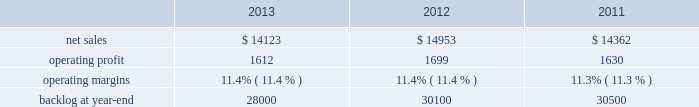Aeronautics our aeronautics business segment is engaged in the research , design , development , manufacture , integration , sustainment , support , and upgrade of advanced military aircraft , including combat and air mobility aircraft , unmanned air vehicles , and related technologies .
Aeronautics 2019 major programs include the f-35 lightning ii joint strike fighter , c-130 hercules , f-16 fighting falcon , f-22 raptor , and the c-5m super galaxy .
Aeronautics 2019 operating results included the following ( in millions ) : .
2013 compared to 2012 aeronautics 2019 net sales for 2013 decreased $ 830 million , or 6% ( 6 % ) , compared to 2012 .
The decrease was primarily attributable to lower net sales of approximately $ 530 million for the f-16 program due to fewer aircraft deliveries ( 13 aircraft delivered in 2013 compared to 37 delivered in 2012 ) partially offset by aircraft configuration mix ; about $ 385 million for the c-130 program due to fewer aircraft deliveries ( 25 aircraft delivered in 2013 compared to 34 in 2012 ) partially offset by increased sustainment activities ; approximately $ 255 million for the f-22 program , which includes about $ 205 million due to decreased production volume as final aircraft deliveries were completed during the second quarter of 2012 and $ 50 million from the favorable resolution of a contractual matter during the second quarter of 2012 ; and about $ 270 million for various other programs ( primarily sustainment activities ) due to decreased volume .
The decreases were partially offset by higher net sales of about $ 295 million for f-35 production contracts due to increased production volume and risk retirements ; approximately $ 245 million for the c-5 program due to increased aircraft deliveries ( six aircraft delivered in 2013 compared to four in 2012 ) and other modernization activities ; and about $ 70 million for the f-35 development contract due to increased volume .
Aeronautics 2019 operating profit for 2013 decreased $ 87 million , or 5% ( 5 % ) , compared to 2012 .
The decrease was primarily attributable to lower operating profit of about $ 85 million for the f-22 program , which includes approximately $ 50 million from the favorable resolution of a contractual matter in the second quarter of 2012 and about $ 35 million due to decreased risk retirements and production volume ; approximately $ 70 million for the c-130 program due to lower risk retirements and fewer deliveries partially offset by increased sustainment activities ; about $ 65 million for the c-5 program due to the inception-to-date effect of reducing the profit booking rate in the third quarter of 2013 and lower risk retirements ; approximately $ 35 million for the f-16 program due to fewer aircraft deliveries partially offset by increased sustainment activity and aircraft configuration mix .
The decreases were partially offset by higher operating profit of approximately $ 180 million for f-35 production contracts due to increased risk retirements and volume .
Operating profit was comparable for the f-35 development contract and included adjustments of approximately $ 85 million to reflect the inception-to-date impacts of the downward revisions to the profit booking rate in both 2013 and 2012 .
Adjustments not related to volume , including net profit booking rate adjustments and other matters , were approximately $ 75 million lower for 2013 compared to 2012 compared to 2011 aeronautics 2019 net sales for 2012 increased $ 591 million , or 4% ( 4 % ) , compared to 2011 .
The increase was attributable to higher net sales of approximately $ 745 million from f-35 production contracts principally due to increased production volume ; about $ 285 million from f-16 programs primarily due to higher aircraft deliveries ( 37 f-16 aircraft delivered in 2012 compared to 22 in 2011 ) partially offset by lower volume on sustainment activities due to the completion of modification programs for certain international customers ; and approximately $ 140 million from c-5 programs due to higher aircraft deliveries ( four c-5m aircraft delivered in 2012 compared to two in 2011 ) .
Partially offsetting the increases were lower net sales of approximately $ 365 million from decreased production volume and lower risk retirements on the f-22 program as final aircraft deliveries were completed in the second quarter of 2012 ; approximately $ 110 million from the f-35 development contract primarily due to the inception-to-date effect of reducing the profit booking rate in the second quarter of 2012 and to a lesser extent lower volume ; and about $ 95 million from a decrease in volume on other sustainment activities partially offset by various other aeronautics programs due to higher volume .
Net sales for c-130 programs were comparable to 2011 as a decline in sustainment activities largely was offset by increased aircraft deliveries. .
What was the average net sales from 2011 to 2013? 
Computations: (((14123 + 14953) + 14362) / 3)
Answer: 14479.33333. 